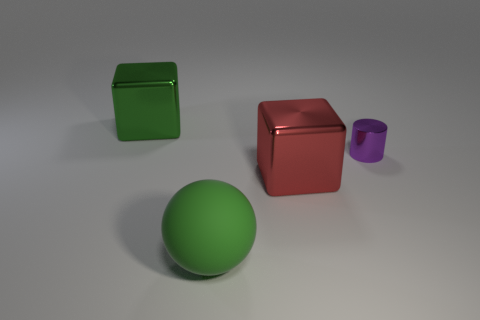Add 1 big cylinders. How many objects exist? 5 Subtract all balls. How many objects are left? 3 Add 4 small purple things. How many small purple things exist? 5 Subtract 1 green balls. How many objects are left? 3 Subtract all large balls. Subtract all big yellow rubber things. How many objects are left? 3 Add 1 balls. How many balls are left? 2 